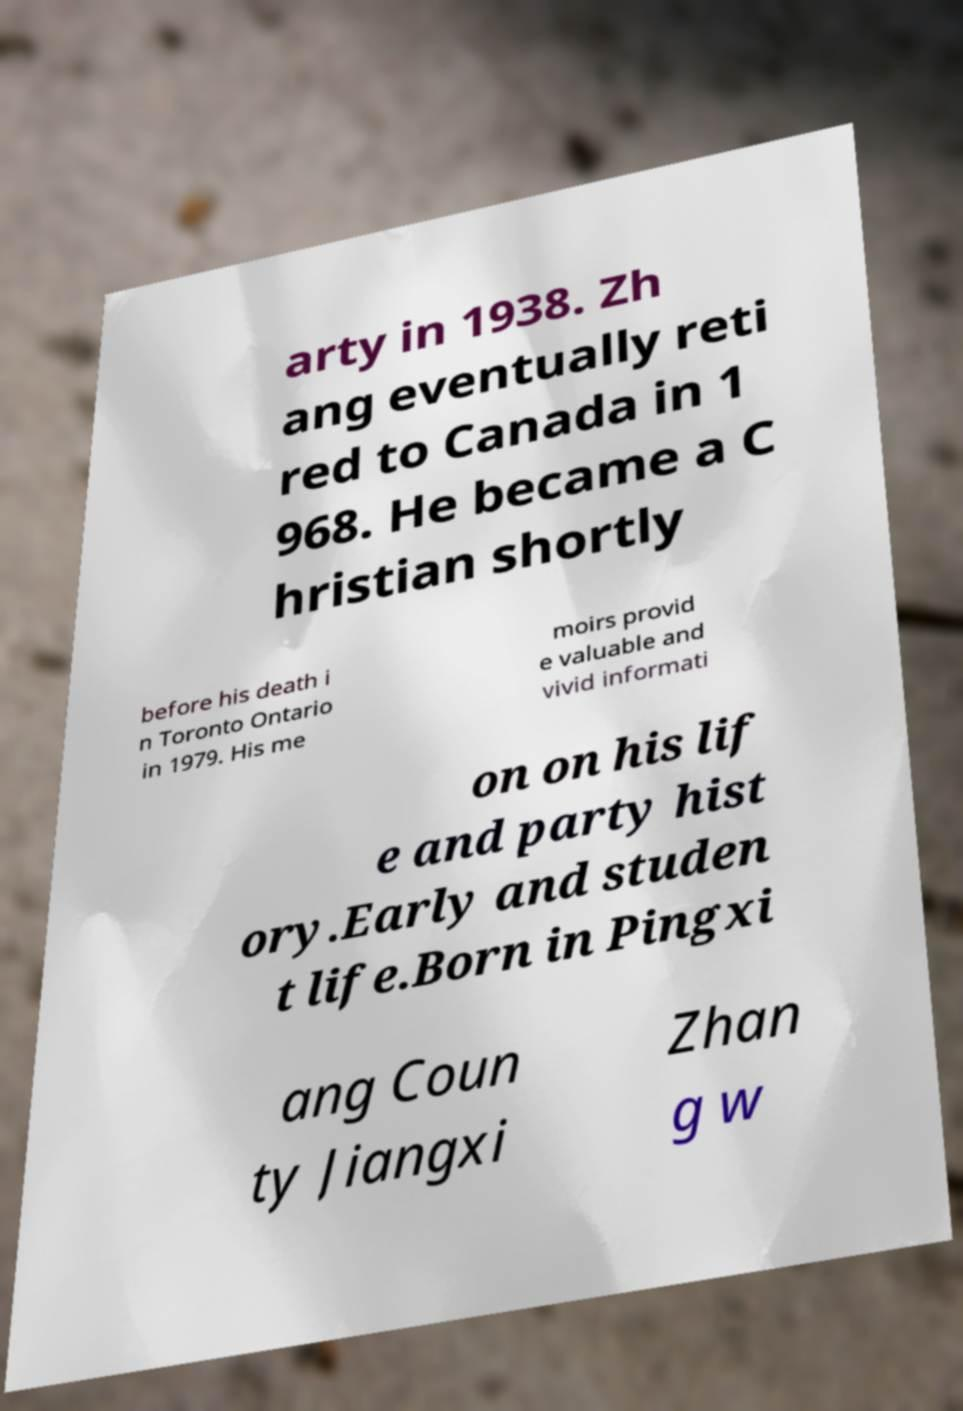For documentation purposes, I need the text within this image transcribed. Could you provide that? arty in 1938. Zh ang eventually reti red to Canada in 1 968. He became a C hristian shortly before his death i n Toronto Ontario in 1979. His me moirs provid e valuable and vivid informati on on his lif e and party hist ory.Early and studen t life.Born in Pingxi ang Coun ty Jiangxi Zhan g w 